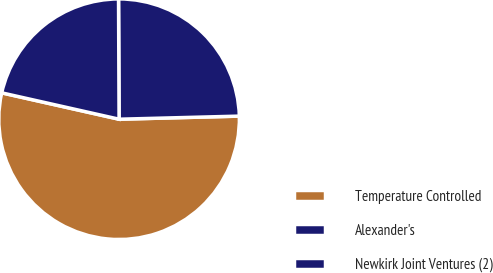<chart> <loc_0><loc_0><loc_500><loc_500><pie_chart><fcel>Temperature Controlled<fcel>Alexander's<fcel>Newkirk Joint Ventures (2)<nl><fcel>53.93%<fcel>24.66%<fcel>21.41%<nl></chart> 